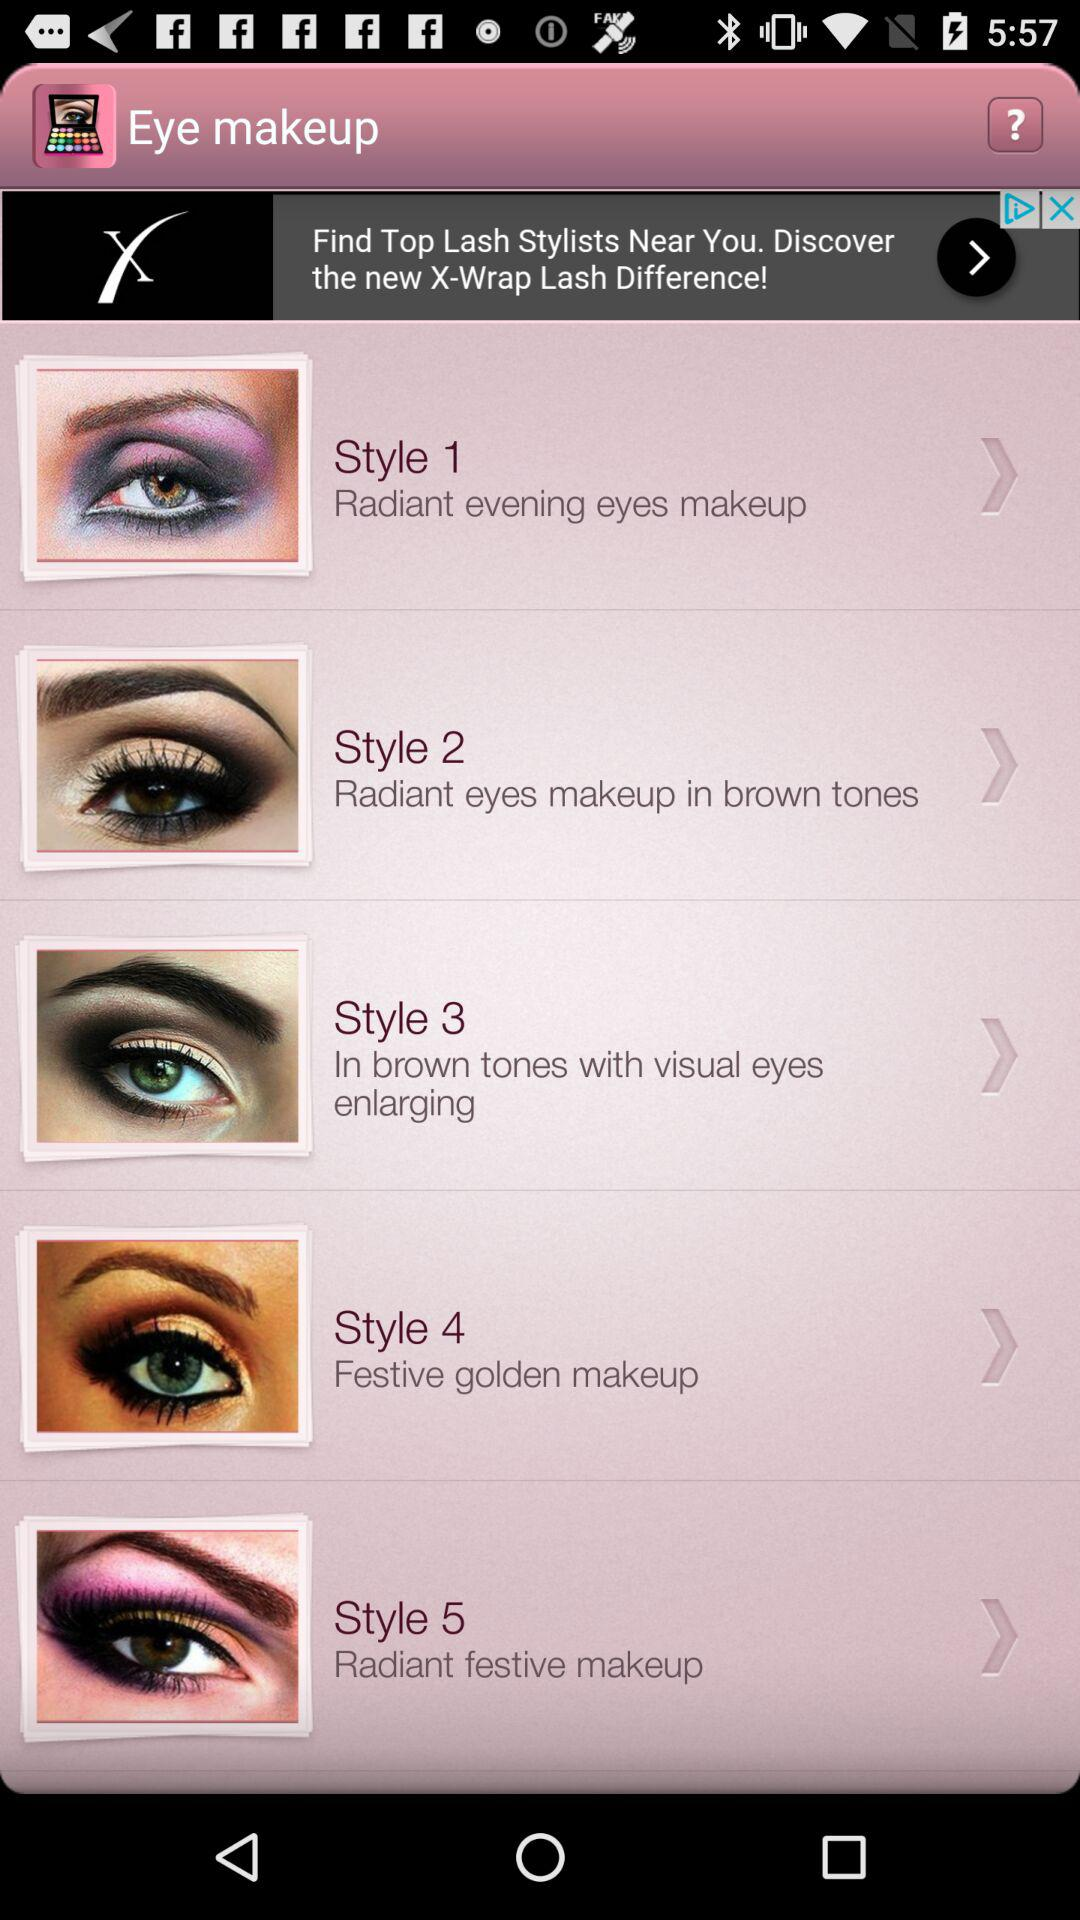How many makeup styles are there in total?
Answer the question using a single word or phrase. 5 